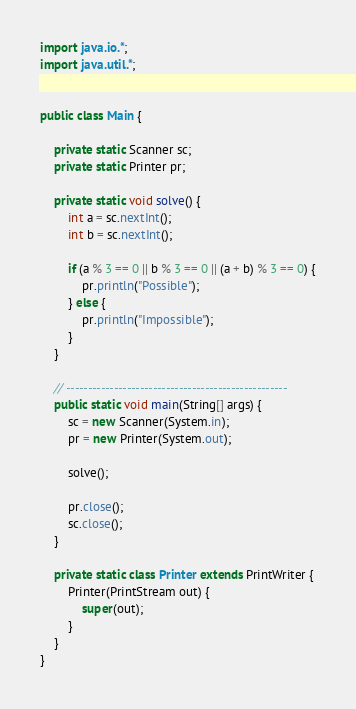<code> <loc_0><loc_0><loc_500><loc_500><_Java_>import java.io.*;
import java.util.*;


public class Main {

	private static Scanner sc;
	private static Printer pr;

	private static void solve() {
		int a = sc.nextInt();
		int b = sc.nextInt();

		if (a % 3 == 0 || b % 3 == 0 || (a + b) % 3 == 0) {
			pr.println("Possible");
		} else {
			pr.println("Impossible");
		}
	}

	// ---------------------------------------------------
	public static void main(String[] args) {
		sc = new Scanner(System.in);
		pr = new Printer(System.out);

		solve();

		pr.close();
		sc.close();
	}

	private static class Printer extends PrintWriter {
		Printer(PrintStream out) {
			super(out);
		}
	}
}
</code> 